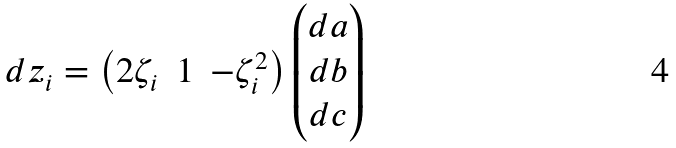Convert formula to latex. <formula><loc_0><loc_0><loc_500><loc_500>d z _ { i } = \begin{pmatrix} 2 \zeta _ { i } & 1 & - \zeta _ { i } ^ { 2 } \end{pmatrix} \begin{pmatrix} d a \\ d b \\ d c \end{pmatrix}</formula> 